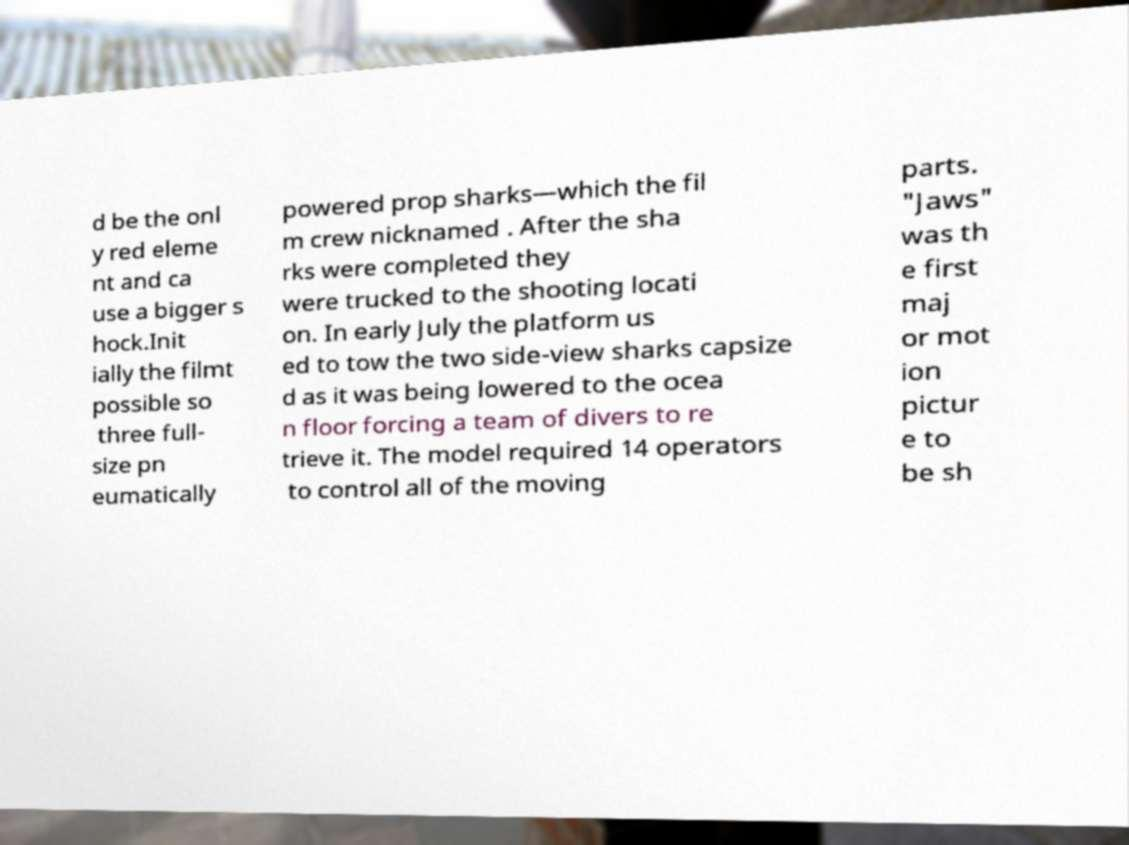Please identify and transcribe the text found in this image. d be the onl y red eleme nt and ca use a bigger s hock.Init ially the filmt possible so three full- size pn eumatically powered prop sharks—which the fil m crew nicknamed . After the sha rks were completed they were trucked to the shooting locati on. In early July the platform us ed to tow the two side-view sharks capsize d as it was being lowered to the ocea n floor forcing a team of divers to re trieve it. The model required 14 operators to control all of the moving parts. "Jaws" was th e first maj or mot ion pictur e to be sh 